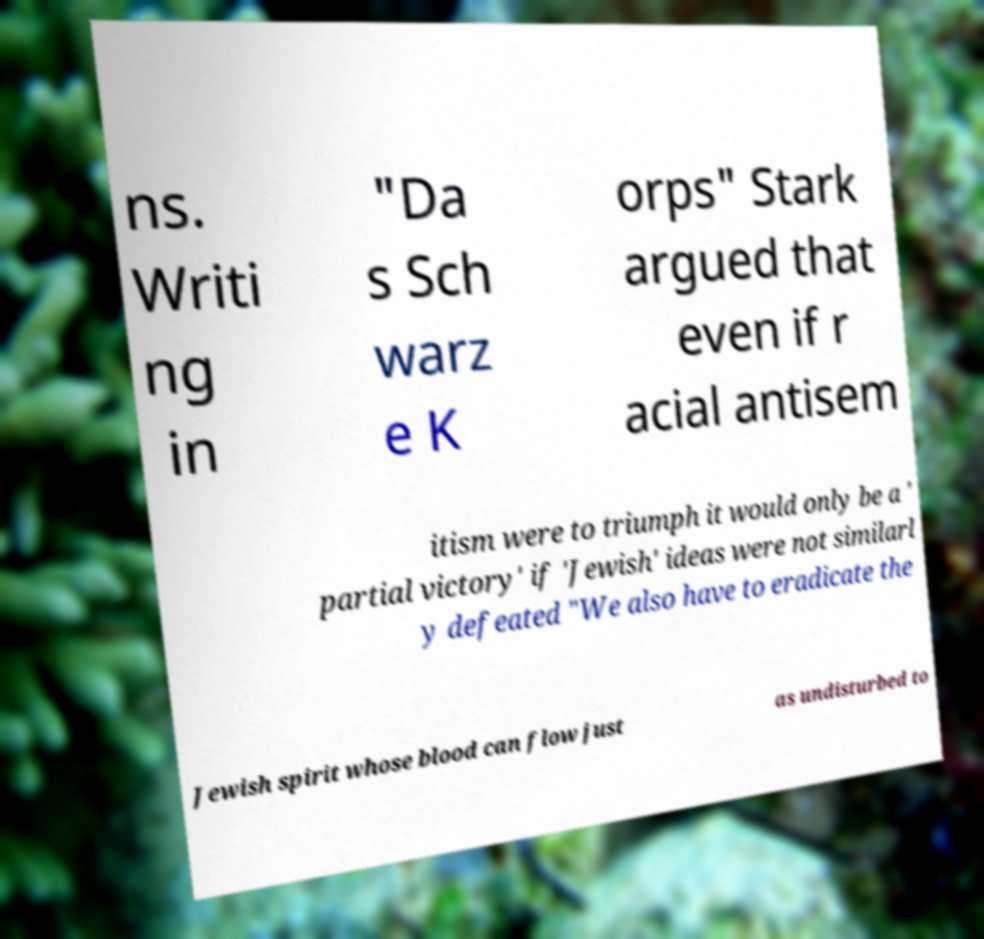Could you assist in decoding the text presented in this image and type it out clearly? ns. Writi ng in "Da s Sch warz e K orps" Stark argued that even if r acial antisem itism were to triumph it would only be a ' partial victory' if 'Jewish' ideas were not similarl y defeated "We also have to eradicate the Jewish spirit whose blood can flow just as undisturbed to 